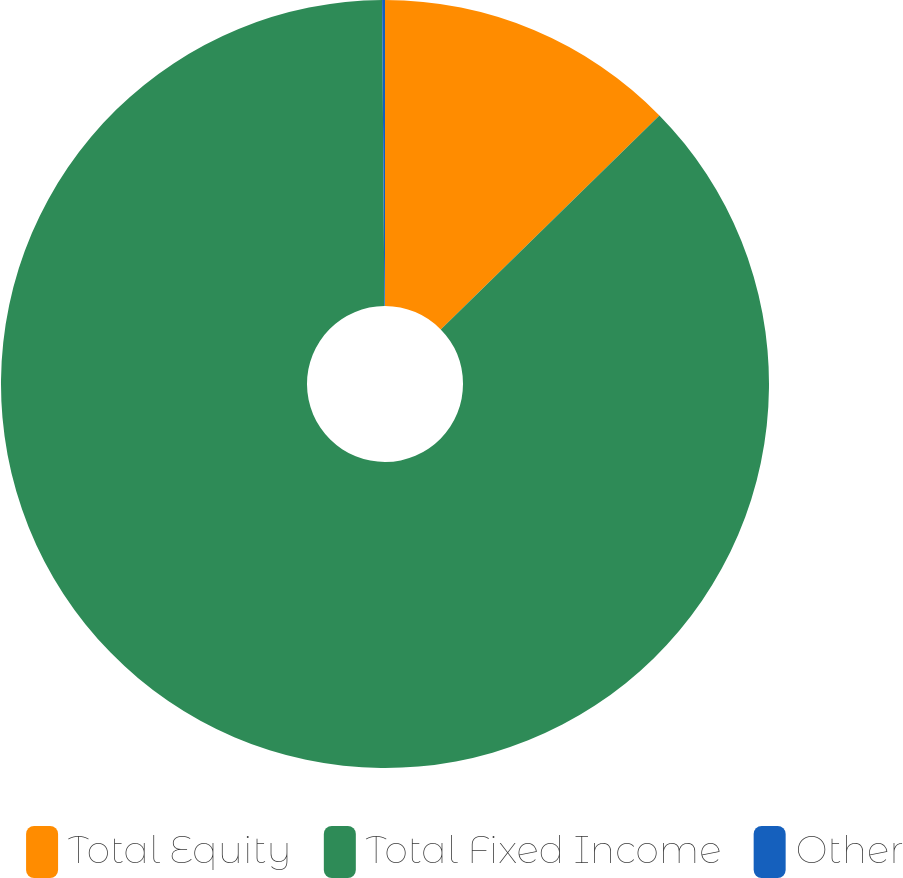Convert chart to OTSL. <chart><loc_0><loc_0><loc_500><loc_500><pie_chart><fcel>Total Equity<fcel>Total Fixed Income<fcel>Other<nl><fcel>12.67%<fcel>87.21%<fcel>0.12%<nl></chart> 